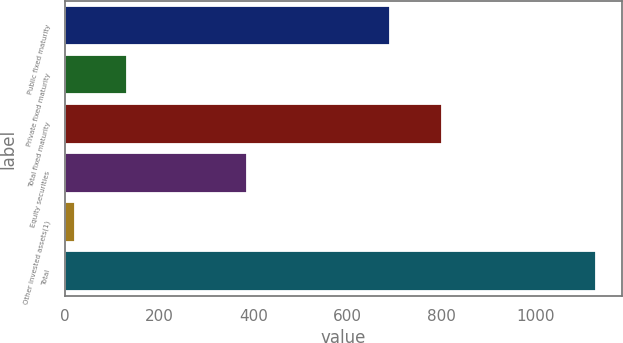Convert chart to OTSL. <chart><loc_0><loc_0><loc_500><loc_500><bar_chart><fcel>Public fixed maturity<fcel>Private fixed maturity<fcel>Total fixed maturity<fcel>Equity securities<fcel>Other invested assets(1)<fcel>Total<nl><fcel>690<fcel>132.5<fcel>800.5<fcel>387<fcel>22<fcel>1127<nl></chart> 